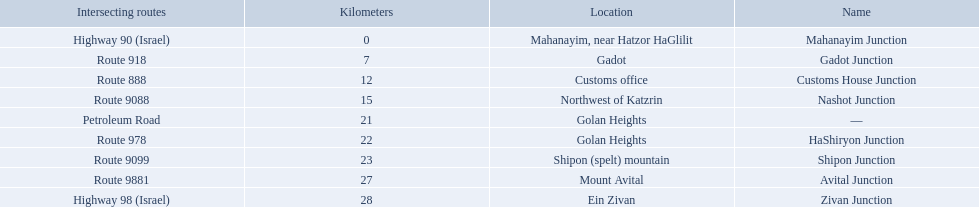How many kilometers away is shipon junction? 23. How many kilometers away is avital junction? 27. Which one is closer to nashot junction? Shipon Junction. 